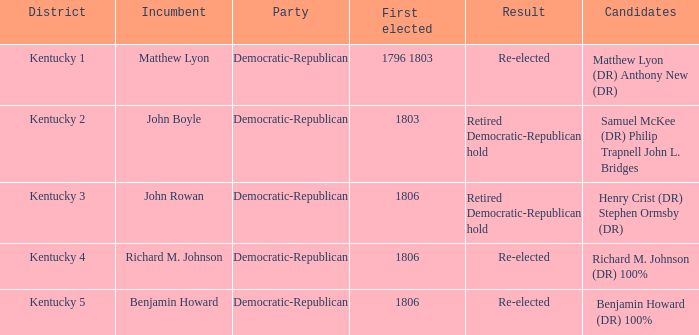Name the first elected for kentucky 1 1796 1803. 